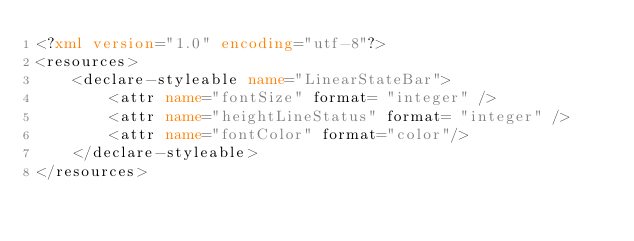Convert code to text. <code><loc_0><loc_0><loc_500><loc_500><_XML_><?xml version="1.0" encoding="utf-8"?>
<resources>
    <declare-styleable name="LinearStateBar">
        <attr name="fontSize" format= "integer" />
        <attr name="heightLineStatus" format= "integer" />
        <attr name="fontColor" format="color"/>
    </declare-styleable>
</resources></code> 